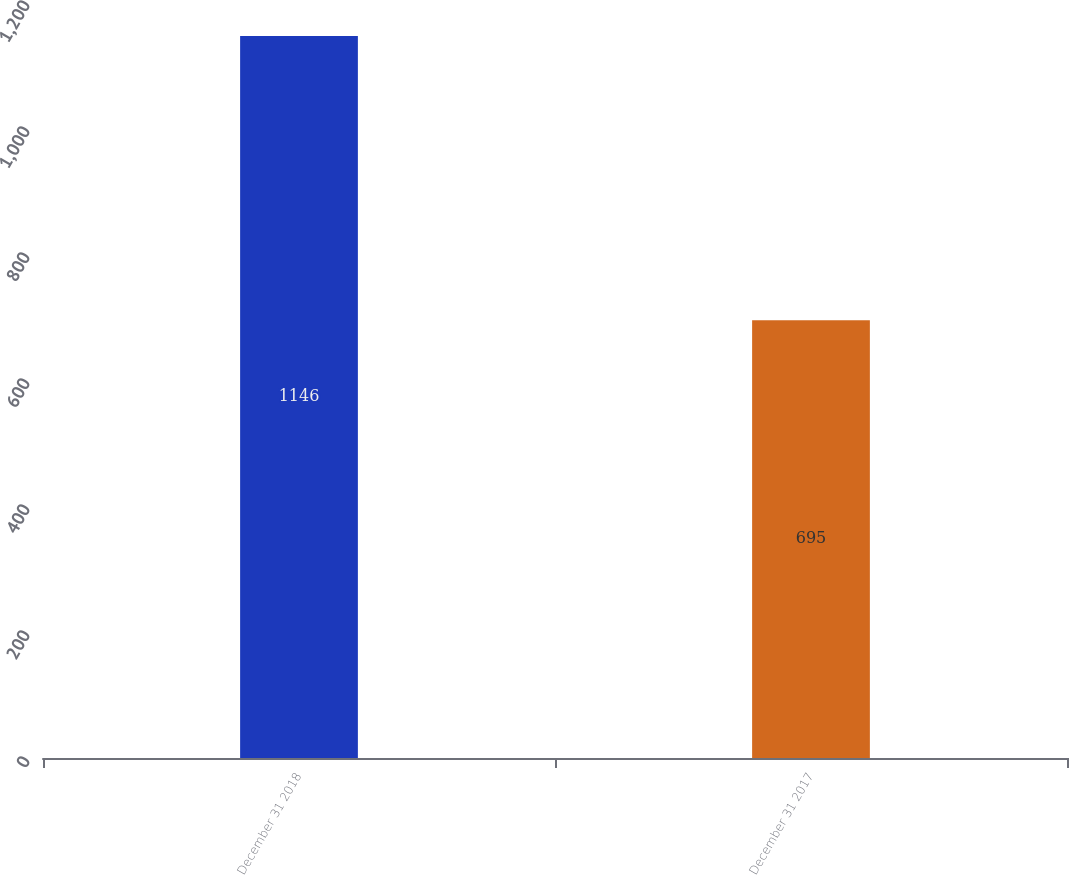Convert chart. <chart><loc_0><loc_0><loc_500><loc_500><bar_chart><fcel>December 31 2018<fcel>December 31 2017<nl><fcel>1146<fcel>695<nl></chart> 